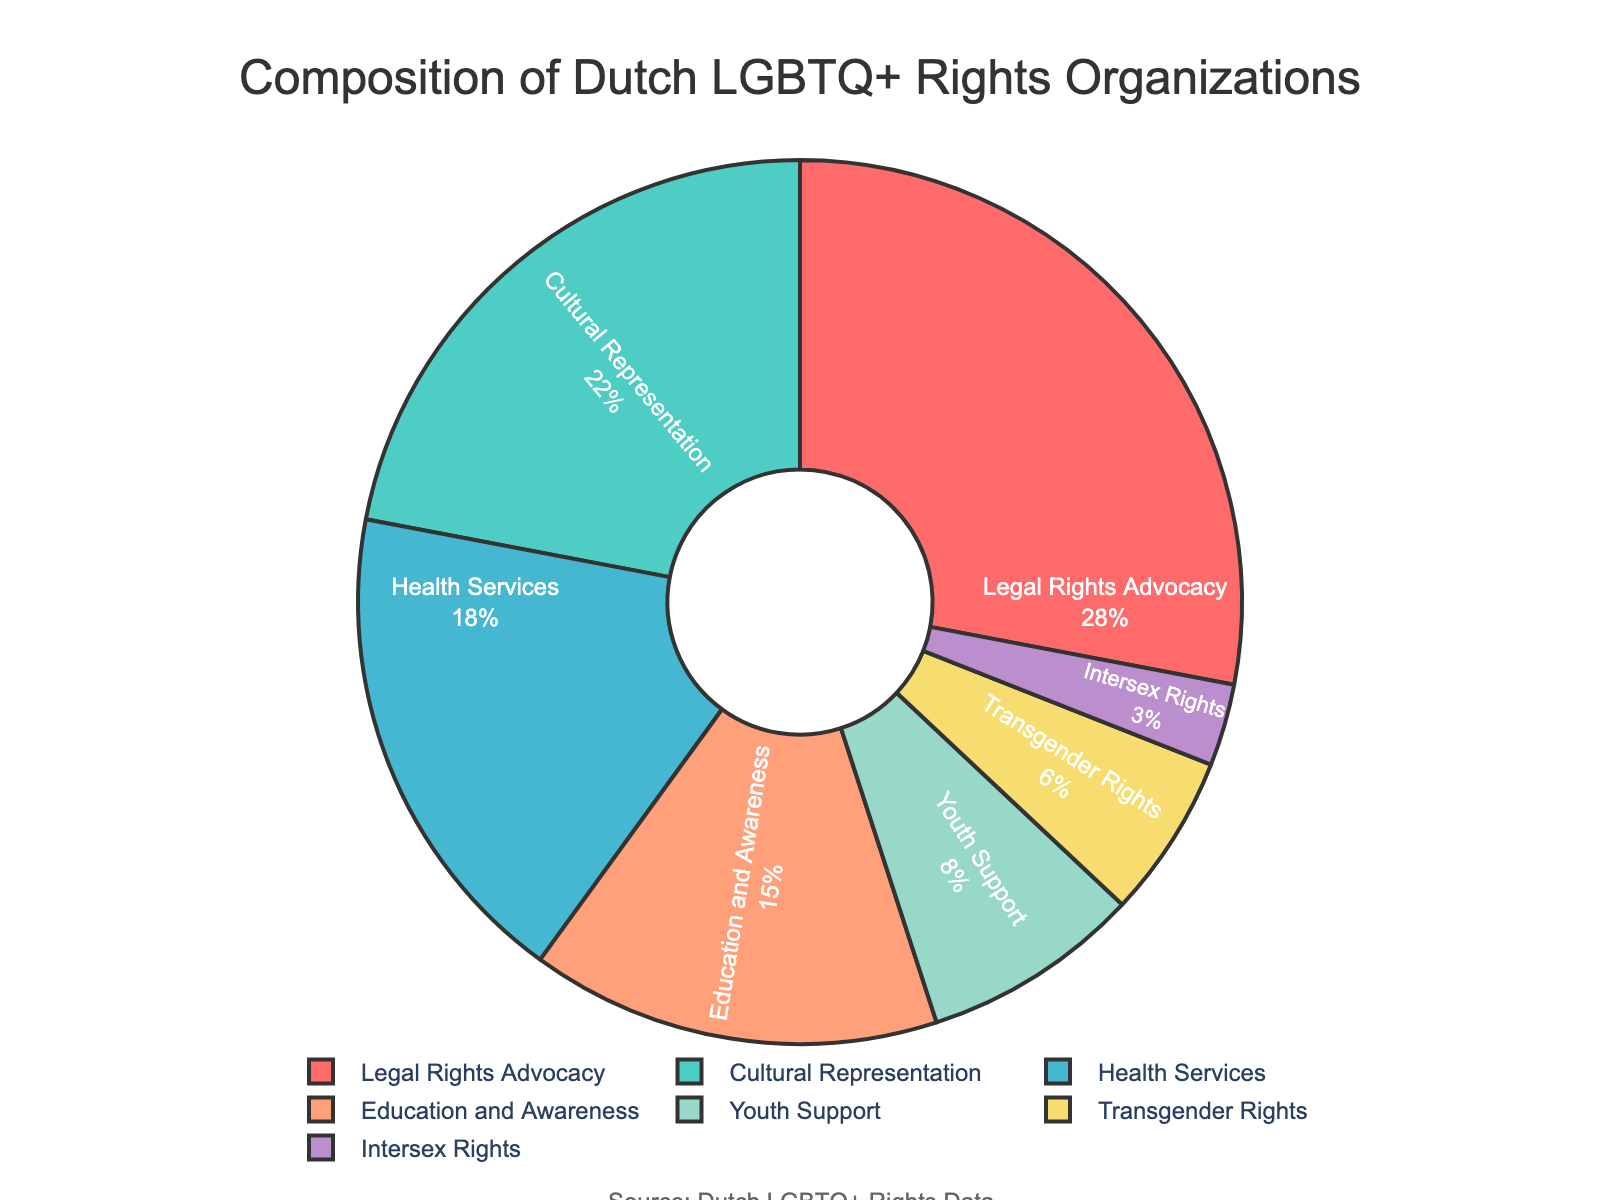What percentage of Dutch LGBTQ+ rights organizations focus on Youth Support and Transgender Rights combined? Youth Support is 8% and Transgender Rights is 6%. Adding these together gives 8% + 6% = 14%.
Answer: 14% Which focus area has the highest representation among Dutch LGBTQ+ rights organizations? The focus area with the highest percentage is Legal Rights Advocacy with 28%.
Answer: Legal Rights Advocacy How does the percentage of organizations focusing on Cultural Representation compare to those focusing on Health Services? Cultural Representation has 22%, while Health Services has 18%. Comparing these, Cultural Representation is 4% higher than Health Services.
Answer: 4% higher Which focus area has the smallest representation, and what percentage is it? The smallest representation is for Intersex Rights at 3%.
Answer: Intersex Rights, 3% What is the total percentage of organizations focusing on areas other than Legal Rights Advocacy and Cultural Representation? Legal Rights Advocacy is 28% and Cultural Representation is 22%. The total percentage for all areas is 100%, so subtracting these (100% - 28% - 22%) gives 50%.
Answer: 50% What is the difference between the percentage of organizations focusing on Education and Awareness and those focusing on Transgender Rights? Education and Awareness is 15%, and Transgender Rights is 6%. The difference is 15% - 6% = 9%.
Answer: 9% Which focus areas together account for more than half of the Dutch LGBTQ+ rights organizations' focus? Legal Rights Advocacy (28%) + Cultural Representation (22%) gives 50%, which does not exceed half. Including Health Services (18%) gives 50% + 18% = 68%, which is more than half. So, these three areas together (Legal Rights Advocacy, Cultural Representation, Health Services) account for more than half.
Answer: Legal Rights Advocacy, Cultural Representation, Health Services What is the combined percentage of organizations focusing on Intersex Rights, Transgender Rights, and Youth Support? Intersex Rights is 3%, Transgender Rights is 6%, and Youth Support is 8%. Summing these gives 3% + 6% + 8% = 17%.
Answer: 17% Which focus area, represented by a yellow segment in the pie chart, has a specific percentage? The color yellow represents Health Services, which has a focus area percentage of 18%.
Answer: Health Services, 18% By how much do organizations focusing on Youth Support outnumber those focusing on Intersex Rights? Youth Support is at 8%, and Intersex Rights is at 3%. The difference is 8% - 3% = 5%.
Answer: 5% 